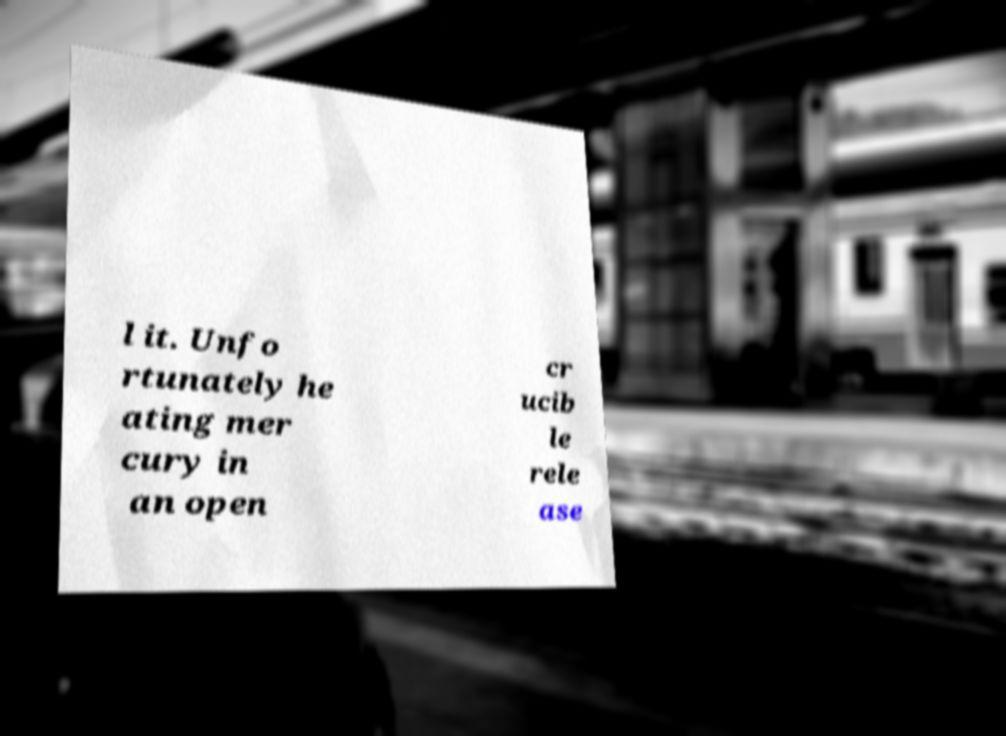Please read and relay the text visible in this image. What does it say? l it. Unfo rtunately he ating mer cury in an open cr ucib le rele ase 